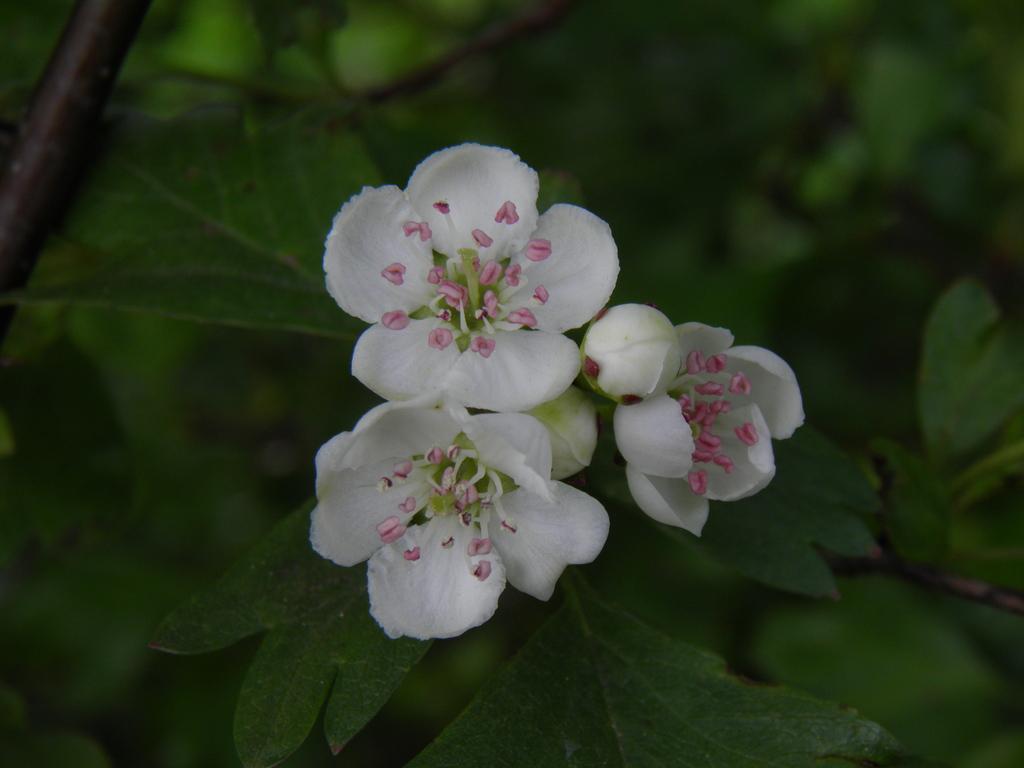How would you summarize this image in a sentence or two? In this picture there are white colors on the plant and there are buds on the plant. 